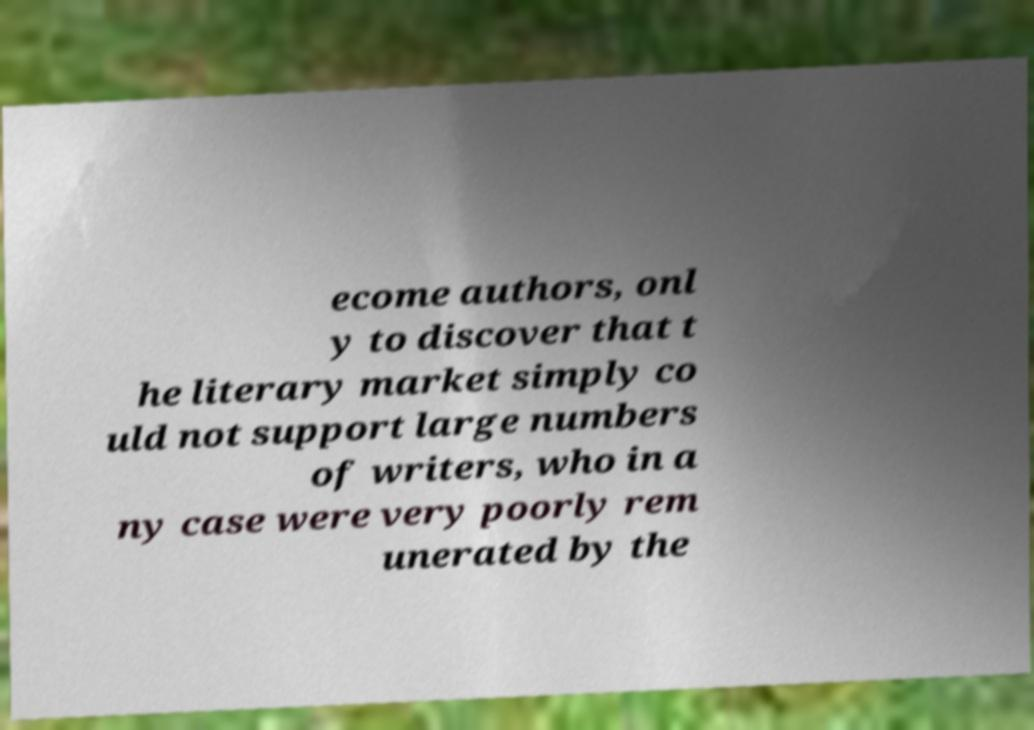I need the written content from this picture converted into text. Can you do that? ecome authors, onl y to discover that t he literary market simply co uld not support large numbers of writers, who in a ny case were very poorly rem unerated by the 